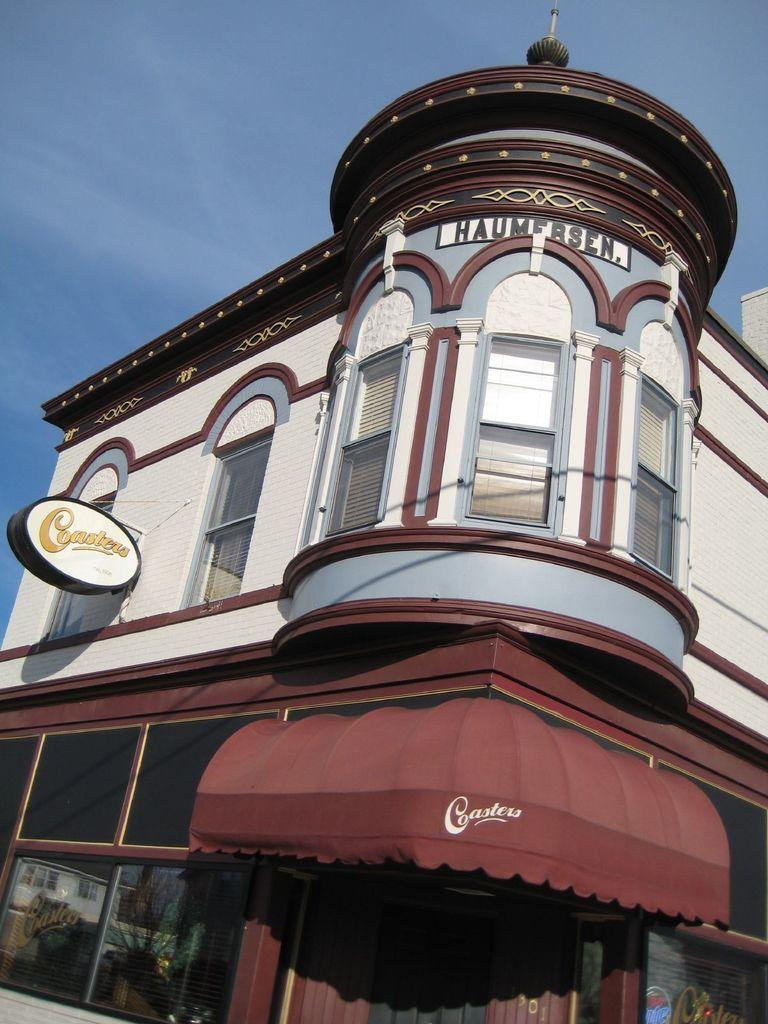What type of structure is present in the image? There is a building in the image. What feature of the building can be seen in the image? There are windows visible in the image. What can be seen in the background of the image? The sky is visible in the background of the image. Where can the twig be found in the image? There is no twig present in the image. What type of haircut is the building sporting in the image? The building does not have a haircut, as it is an inanimate object. 